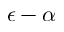Convert formula to latex. <formula><loc_0><loc_0><loc_500><loc_500>\epsilon - \alpha</formula> 